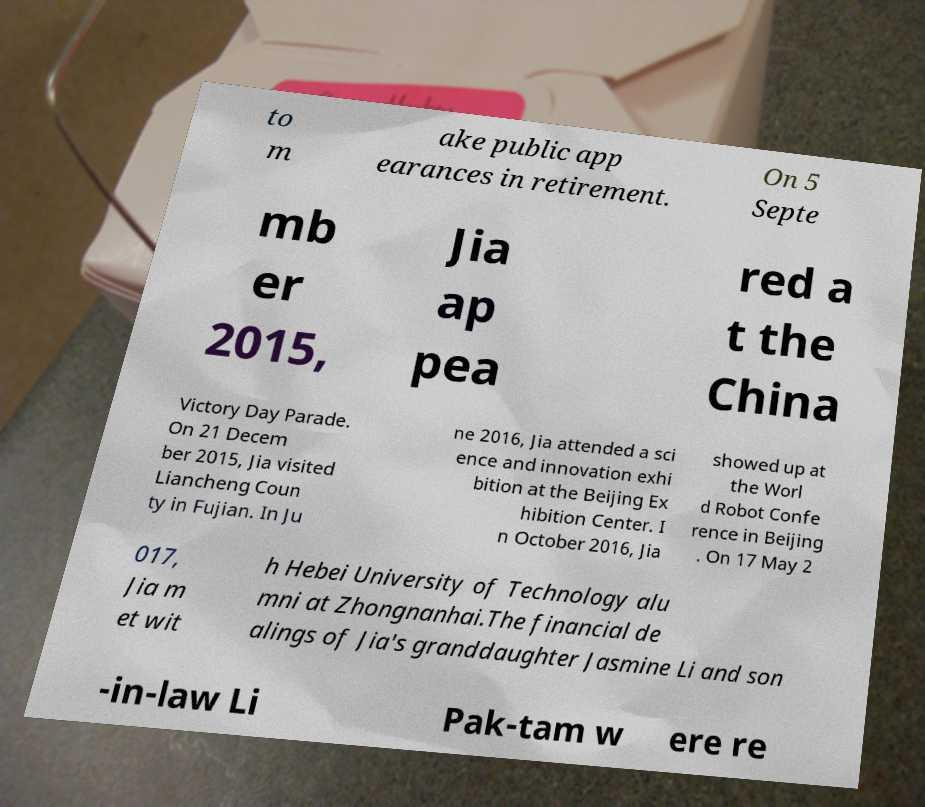Can you read and provide the text displayed in the image?This photo seems to have some interesting text. Can you extract and type it out for me? to m ake public app earances in retirement. On 5 Septe mb er 2015, Jia ap pea red a t the China Victory Day Parade. On 21 Decem ber 2015, Jia visited Liancheng Coun ty in Fujian. In Ju ne 2016, Jia attended a sci ence and innovation exhi bition at the Beijing Ex hibition Center. I n October 2016, Jia showed up at the Worl d Robot Confe rence in Beijing . On 17 May 2 017, Jia m et wit h Hebei University of Technology alu mni at Zhongnanhai.The financial de alings of Jia's granddaughter Jasmine Li and son -in-law Li Pak-tam w ere re 